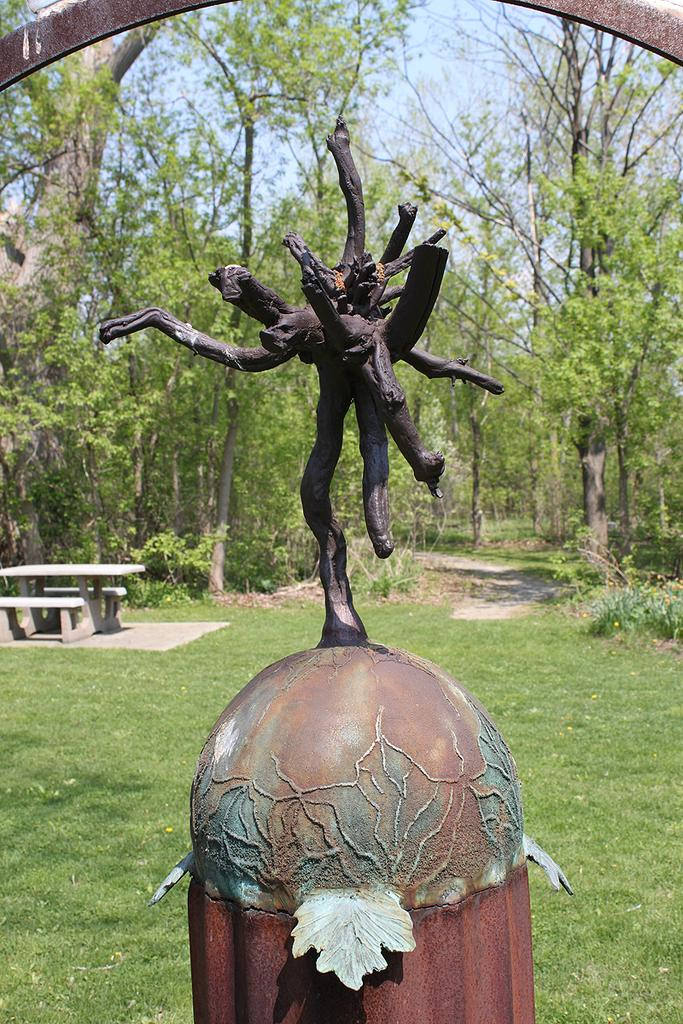What is the main subject of the image? There is a sculpture in the image. What can be seen in the background of the image? There is a bench and trees in the background of the image. What type of vegetation covers the land in the image? The land is covered with grass. Can you tell me what type of berry is growing on the sculpture in the image? There are no berries present on the sculpture in the image. What is the sculpture using to carry the yoke in the image? There is no yoke present in the image, and the sculpture is not carrying anything. 